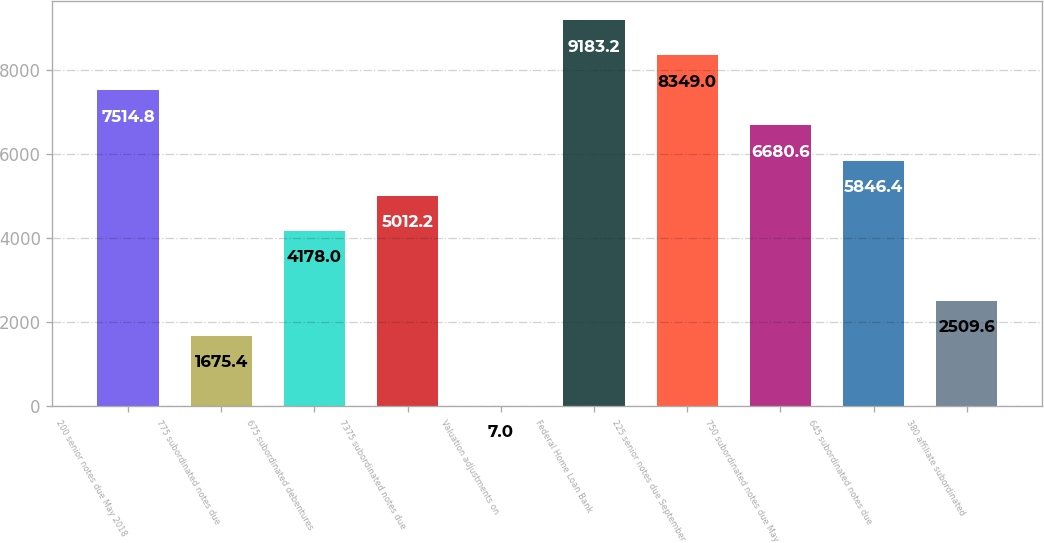Convert chart to OTSL. <chart><loc_0><loc_0><loc_500><loc_500><bar_chart><fcel>200 senior notes due May 2018<fcel>775 subordinated notes due<fcel>675 subordinated debentures<fcel>7375 subordinated notes due<fcel>Valuation adjustments on<fcel>Federal Home Loan Bank<fcel>225 senior notes due September<fcel>750 subordinated notes due May<fcel>645 subordinated notes due<fcel>380 affiliate subordinated<nl><fcel>7514.8<fcel>1675.4<fcel>4178<fcel>5012.2<fcel>7<fcel>9183.2<fcel>8349<fcel>6680.6<fcel>5846.4<fcel>2509.6<nl></chart> 